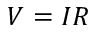Convert formula to latex. <formula><loc_0><loc_0><loc_500><loc_500>V = I R</formula> 